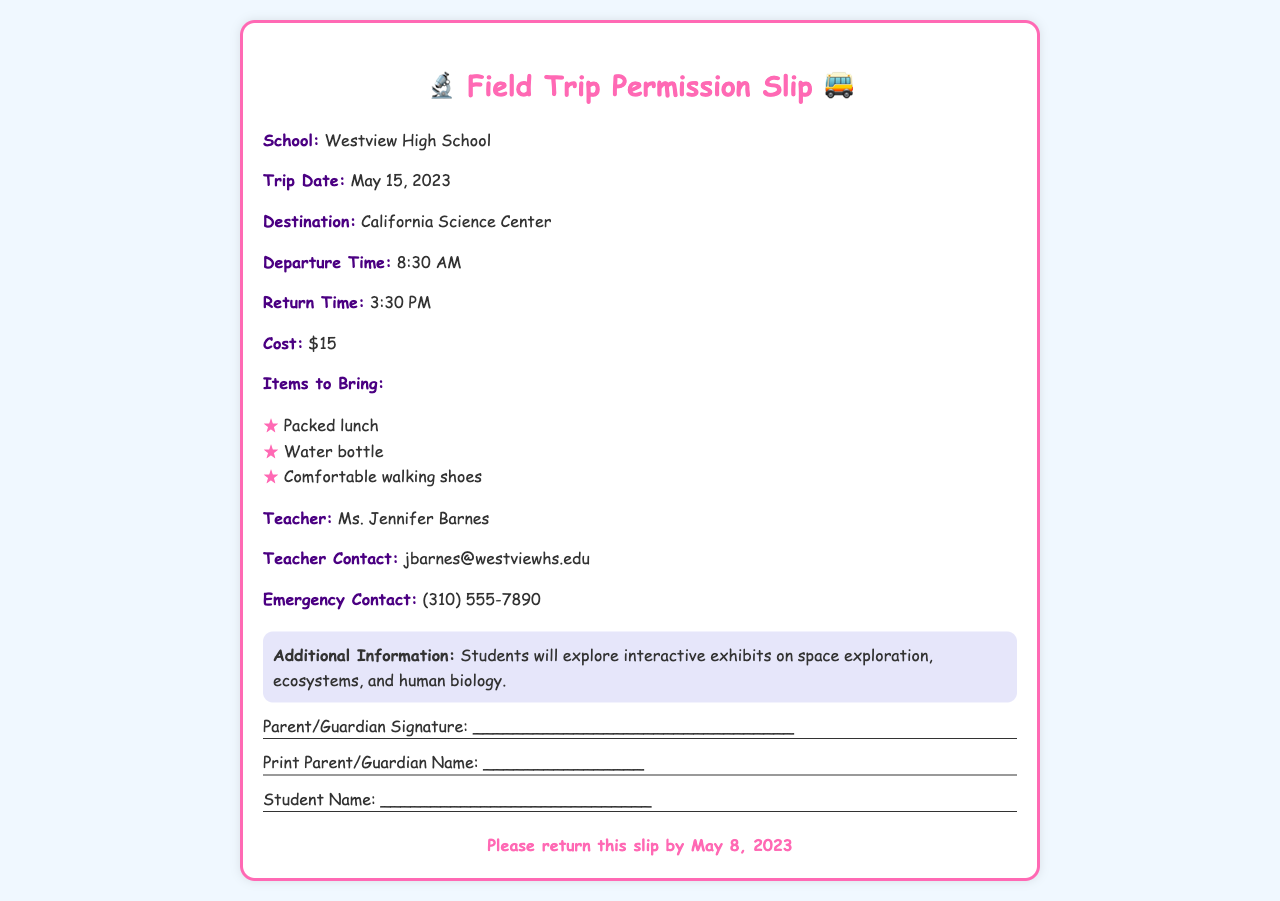What is the school name? The school name is explicitly stated in the document, identifying where the field trip originates.
Answer: Westview High School What is the trip date? The trip date is provided in the document as the specific day the field trip is scheduled to occur.
Answer: May 15, 2023 What is the destination of the trip? The destination is clearly mentioned in the document, indicating where the students will be going.
Answer: California Science Center What time do they depart? The departure time is specified in the document, indicating when the students will leave for the trip.
Answer: 8:30 AM What is the cost of the trip? The cost is outlined in the document, providing information about the price that students need to pay.
Answer: $15 What items should students bring? The document lists necessary items, emphasizing what students need to prepare for the trip.
Answer: Packed lunch, Water bottle, Comfortable walking shoes Who is the teacher in charge? The document names the teacher responsible for supervising the trip, giving insight into who to contact for questions.
Answer: Ms. Jennifer Barnes What is the emergency contact number? The document includes an emergency contact number, offering information for urgent situations on the trip.
Answer: (310) 555-7890 When is the permission slip due? The deadline for returning the permission slip is provided, marking an important date for parents and students.
Answer: May 8, 2023 